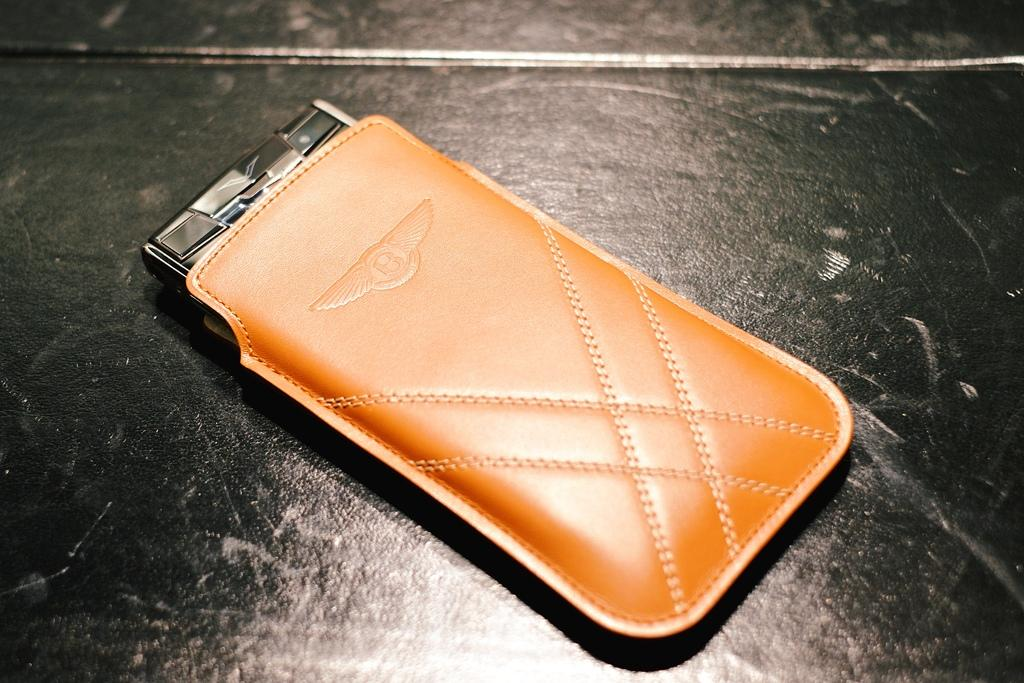What electronic device is visible in the image? There is a mobile phone in the image. Is there any accessory for the mobile phone in the image? Yes, the mobile phone has a pouch. Where are the mobile phone and pouch located? The mobile phone and pouch are on a table. What type of good-bye message can be seen on the mobile phone in the image? There is no good-bye message visible on the mobile phone in the image. 